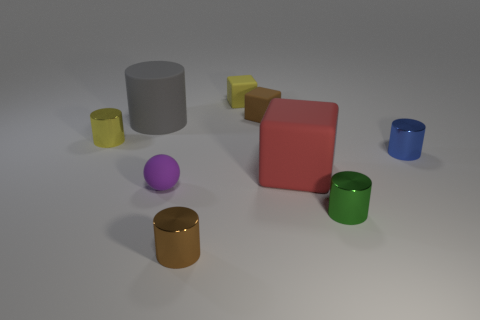Subtract all yellow shiny cylinders. How many cylinders are left? 4 Subtract all blue cylinders. How many cylinders are left? 4 Subtract all cyan cylinders. Subtract all gray blocks. How many cylinders are left? 5 Subtract 0 red balls. How many objects are left? 9 Subtract all cubes. How many objects are left? 6 Subtract all big yellow balls. Subtract all small purple matte spheres. How many objects are left? 8 Add 9 tiny yellow cylinders. How many tiny yellow cylinders are left? 10 Add 6 big red matte things. How many big red matte things exist? 7 